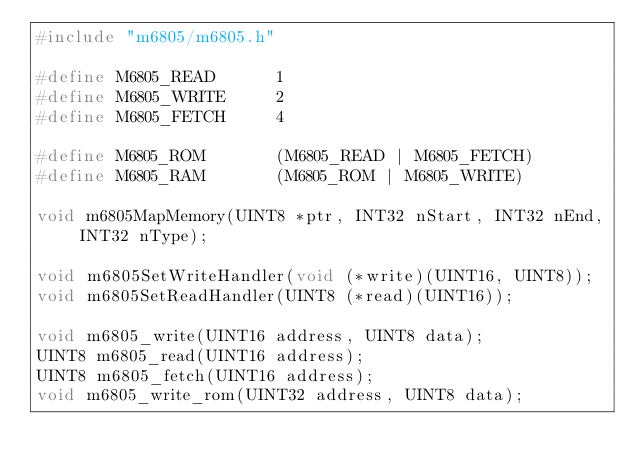<code> <loc_0><loc_0><loc_500><loc_500><_C_>#include "m6805/m6805.h"

#define M6805_READ		1
#define M6805_WRITE		2
#define M6805_FETCH		4

#define M6805_ROM		(M6805_READ | M6805_FETCH)
#define M6805_RAM		(M6805_ROM | M6805_WRITE)

void m6805MapMemory(UINT8 *ptr, INT32 nStart, INT32 nEnd, INT32 nType);

void m6805SetWriteHandler(void (*write)(UINT16, UINT8));
void m6805SetReadHandler(UINT8 (*read)(UINT16));

void m6805_write(UINT16 address, UINT8 data);
UINT8 m6805_read(UINT16 address);
UINT8 m6805_fetch(UINT16 address);
void m6805_write_rom(UINT32 address, UINT8 data);
</code> 